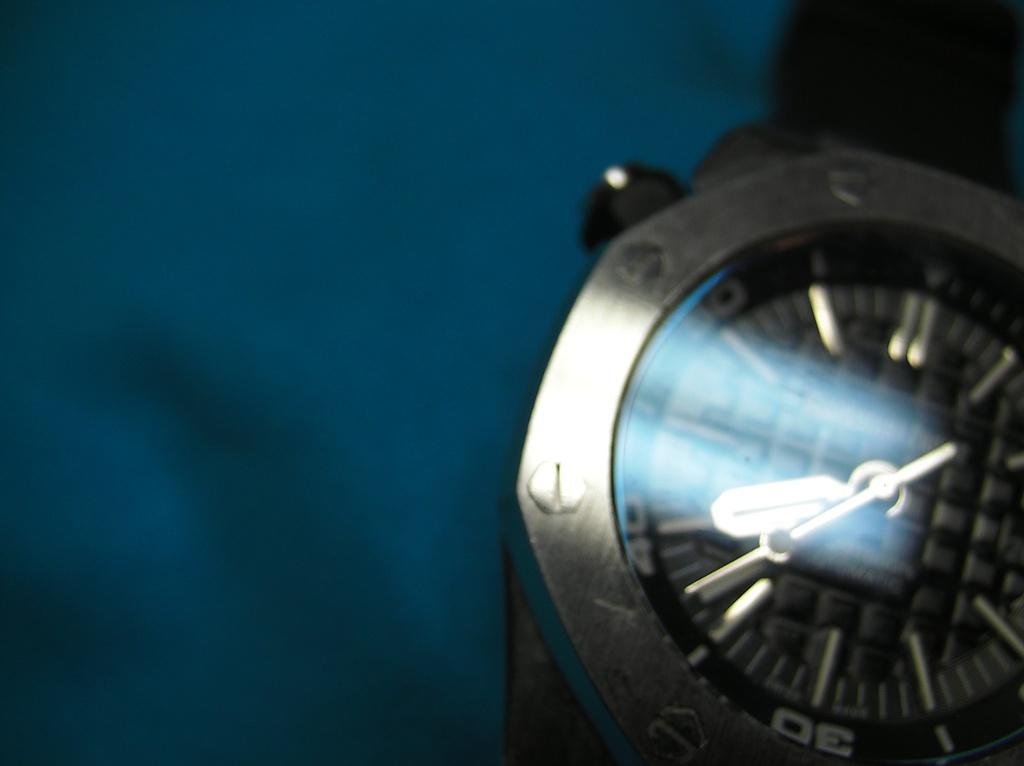<image>
Relay a brief, clear account of the picture shown. A silver wrist watch has the hour numbers marked my tens rather than by single digits. 